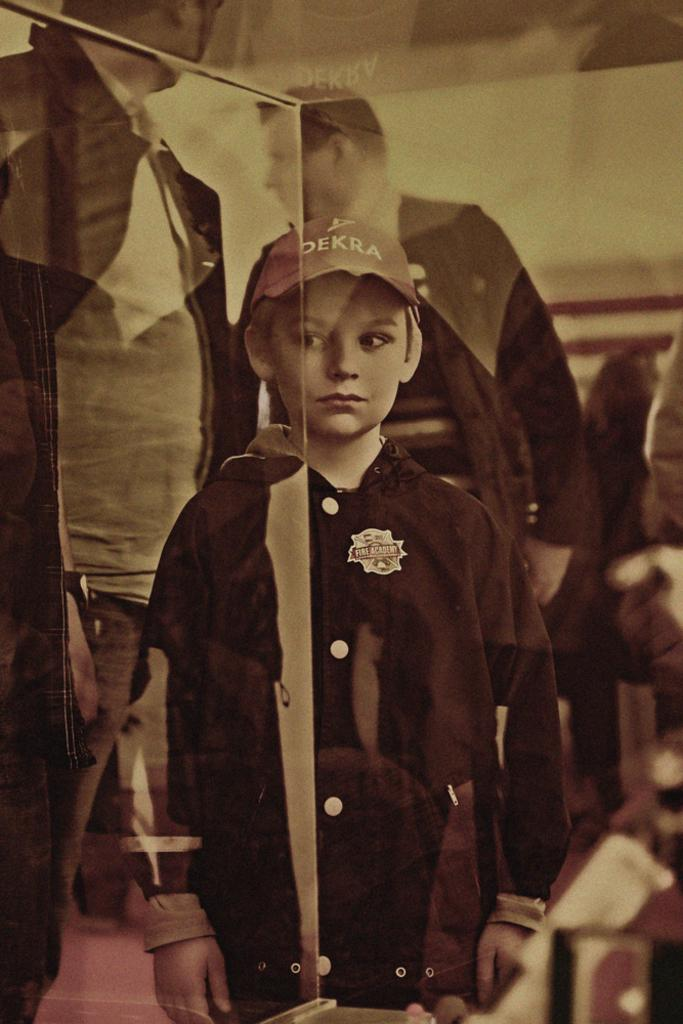What is the main subject of the image? The main subject of the image is a boy standing. Can you describe the setting of the image? There are other people in the background of the image. What is the cause of the ground shaking in the image? There is no indication in the image that the ground is shaking, so it's not possible to determine the cause. 